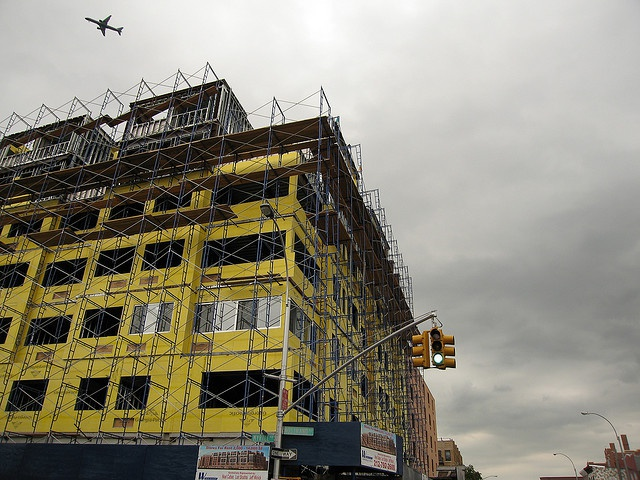Describe the objects in this image and their specific colors. I can see traffic light in darkgray, black, maroon, and olive tones and airplane in darkgray, black, and gray tones in this image. 